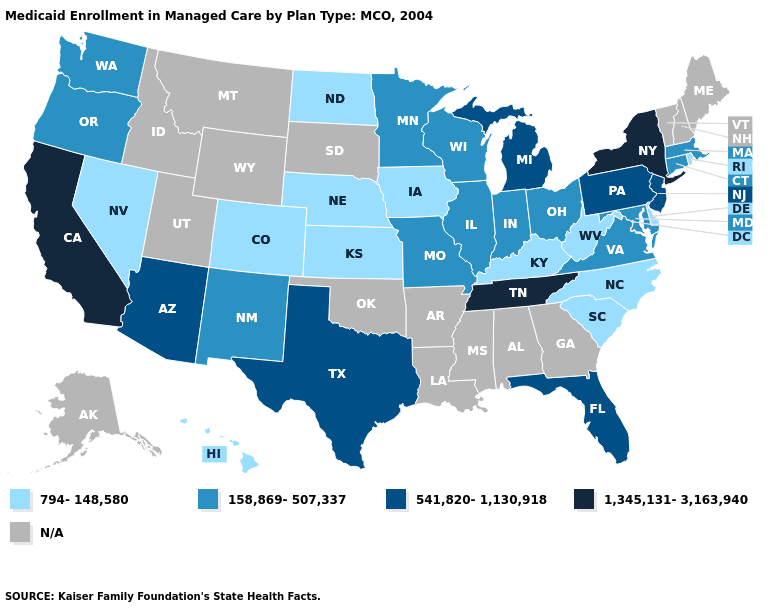Name the states that have a value in the range 1,345,131-3,163,940?
Quick response, please. California, New York, Tennessee. Name the states that have a value in the range 1,345,131-3,163,940?
Short answer required. California, New York, Tennessee. Which states hav the highest value in the West?
Concise answer only. California. How many symbols are there in the legend?
Quick response, please. 5. Name the states that have a value in the range N/A?
Quick response, please. Alabama, Alaska, Arkansas, Georgia, Idaho, Louisiana, Maine, Mississippi, Montana, New Hampshire, Oklahoma, South Dakota, Utah, Vermont, Wyoming. What is the value of Oklahoma?
Quick response, please. N/A. How many symbols are there in the legend?
Concise answer only. 5. What is the lowest value in states that border Kentucky?
Quick response, please. 794-148,580. What is the value of Montana?
Short answer required. N/A. Name the states that have a value in the range 1,345,131-3,163,940?
Quick response, please. California, New York, Tennessee. Name the states that have a value in the range 541,820-1,130,918?
Write a very short answer. Arizona, Florida, Michigan, New Jersey, Pennsylvania, Texas. 